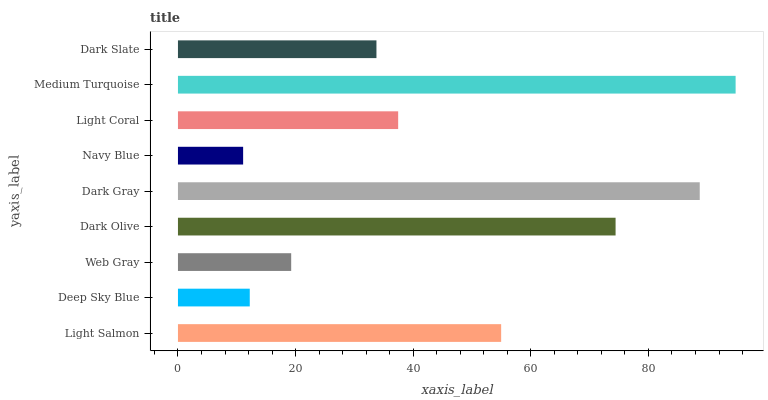Is Navy Blue the minimum?
Answer yes or no. Yes. Is Medium Turquoise the maximum?
Answer yes or no. Yes. Is Deep Sky Blue the minimum?
Answer yes or no. No. Is Deep Sky Blue the maximum?
Answer yes or no. No. Is Light Salmon greater than Deep Sky Blue?
Answer yes or no. Yes. Is Deep Sky Blue less than Light Salmon?
Answer yes or no. Yes. Is Deep Sky Blue greater than Light Salmon?
Answer yes or no. No. Is Light Salmon less than Deep Sky Blue?
Answer yes or no. No. Is Light Coral the high median?
Answer yes or no. Yes. Is Light Coral the low median?
Answer yes or no. Yes. Is Dark Slate the high median?
Answer yes or no. No. Is Deep Sky Blue the low median?
Answer yes or no. No. 